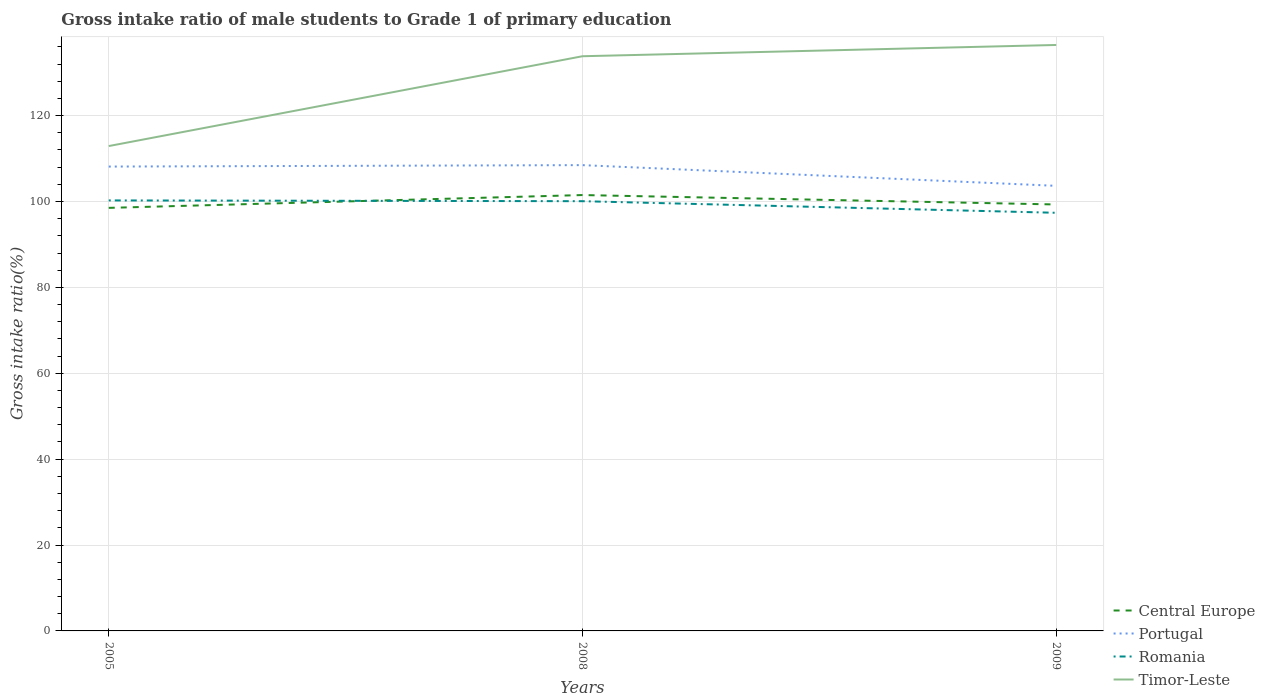How many different coloured lines are there?
Keep it short and to the point. 4. Across all years, what is the maximum gross intake ratio in Timor-Leste?
Offer a very short reply. 112.91. What is the total gross intake ratio in Timor-Leste in the graph?
Give a very brief answer. -2.62. What is the difference between the highest and the second highest gross intake ratio in Central Europe?
Keep it short and to the point. 2.98. Is the gross intake ratio in Portugal strictly greater than the gross intake ratio in Timor-Leste over the years?
Make the answer very short. Yes. How many lines are there?
Provide a short and direct response. 4. Does the graph contain grids?
Offer a very short reply. Yes. Where does the legend appear in the graph?
Provide a succinct answer. Bottom right. How are the legend labels stacked?
Keep it short and to the point. Vertical. What is the title of the graph?
Your answer should be compact. Gross intake ratio of male students to Grade 1 of primary education. What is the label or title of the X-axis?
Keep it short and to the point. Years. What is the label or title of the Y-axis?
Give a very brief answer. Gross intake ratio(%). What is the Gross intake ratio(%) in Central Europe in 2005?
Your response must be concise. 98.51. What is the Gross intake ratio(%) of Portugal in 2005?
Your response must be concise. 108.13. What is the Gross intake ratio(%) of Romania in 2005?
Your answer should be compact. 100.25. What is the Gross intake ratio(%) in Timor-Leste in 2005?
Make the answer very short. 112.91. What is the Gross intake ratio(%) in Central Europe in 2008?
Your answer should be compact. 101.5. What is the Gross intake ratio(%) of Portugal in 2008?
Make the answer very short. 108.47. What is the Gross intake ratio(%) in Romania in 2008?
Your response must be concise. 100.07. What is the Gross intake ratio(%) in Timor-Leste in 2008?
Provide a short and direct response. 133.82. What is the Gross intake ratio(%) of Central Europe in 2009?
Offer a terse response. 99.3. What is the Gross intake ratio(%) in Portugal in 2009?
Your response must be concise. 103.64. What is the Gross intake ratio(%) in Romania in 2009?
Provide a short and direct response. 97.37. What is the Gross intake ratio(%) in Timor-Leste in 2009?
Offer a very short reply. 136.45. Across all years, what is the maximum Gross intake ratio(%) in Central Europe?
Your response must be concise. 101.5. Across all years, what is the maximum Gross intake ratio(%) of Portugal?
Ensure brevity in your answer.  108.47. Across all years, what is the maximum Gross intake ratio(%) in Romania?
Your answer should be very brief. 100.25. Across all years, what is the maximum Gross intake ratio(%) in Timor-Leste?
Keep it short and to the point. 136.45. Across all years, what is the minimum Gross intake ratio(%) of Central Europe?
Provide a short and direct response. 98.51. Across all years, what is the minimum Gross intake ratio(%) of Portugal?
Offer a terse response. 103.64. Across all years, what is the minimum Gross intake ratio(%) of Romania?
Offer a terse response. 97.37. Across all years, what is the minimum Gross intake ratio(%) of Timor-Leste?
Provide a short and direct response. 112.91. What is the total Gross intake ratio(%) of Central Europe in the graph?
Offer a terse response. 299.31. What is the total Gross intake ratio(%) in Portugal in the graph?
Provide a short and direct response. 320.24. What is the total Gross intake ratio(%) of Romania in the graph?
Provide a short and direct response. 297.69. What is the total Gross intake ratio(%) of Timor-Leste in the graph?
Your answer should be compact. 383.18. What is the difference between the Gross intake ratio(%) of Central Europe in 2005 and that in 2008?
Offer a very short reply. -2.98. What is the difference between the Gross intake ratio(%) of Portugal in 2005 and that in 2008?
Make the answer very short. -0.33. What is the difference between the Gross intake ratio(%) in Romania in 2005 and that in 2008?
Make the answer very short. 0.18. What is the difference between the Gross intake ratio(%) of Timor-Leste in 2005 and that in 2008?
Provide a short and direct response. -20.92. What is the difference between the Gross intake ratio(%) of Central Europe in 2005 and that in 2009?
Provide a succinct answer. -0.79. What is the difference between the Gross intake ratio(%) of Portugal in 2005 and that in 2009?
Keep it short and to the point. 4.49. What is the difference between the Gross intake ratio(%) of Romania in 2005 and that in 2009?
Your answer should be compact. 2.88. What is the difference between the Gross intake ratio(%) of Timor-Leste in 2005 and that in 2009?
Your answer should be compact. -23.54. What is the difference between the Gross intake ratio(%) in Central Europe in 2008 and that in 2009?
Provide a short and direct response. 2.19. What is the difference between the Gross intake ratio(%) of Portugal in 2008 and that in 2009?
Offer a terse response. 4.82. What is the difference between the Gross intake ratio(%) in Romania in 2008 and that in 2009?
Give a very brief answer. 2.7. What is the difference between the Gross intake ratio(%) in Timor-Leste in 2008 and that in 2009?
Your answer should be very brief. -2.62. What is the difference between the Gross intake ratio(%) of Central Europe in 2005 and the Gross intake ratio(%) of Portugal in 2008?
Your answer should be very brief. -9.95. What is the difference between the Gross intake ratio(%) in Central Europe in 2005 and the Gross intake ratio(%) in Romania in 2008?
Give a very brief answer. -1.56. What is the difference between the Gross intake ratio(%) in Central Europe in 2005 and the Gross intake ratio(%) in Timor-Leste in 2008?
Make the answer very short. -35.31. What is the difference between the Gross intake ratio(%) in Portugal in 2005 and the Gross intake ratio(%) in Romania in 2008?
Ensure brevity in your answer.  8.06. What is the difference between the Gross intake ratio(%) in Portugal in 2005 and the Gross intake ratio(%) in Timor-Leste in 2008?
Your response must be concise. -25.69. What is the difference between the Gross intake ratio(%) of Romania in 2005 and the Gross intake ratio(%) of Timor-Leste in 2008?
Offer a terse response. -33.58. What is the difference between the Gross intake ratio(%) of Central Europe in 2005 and the Gross intake ratio(%) of Portugal in 2009?
Provide a succinct answer. -5.13. What is the difference between the Gross intake ratio(%) of Central Europe in 2005 and the Gross intake ratio(%) of Romania in 2009?
Give a very brief answer. 1.15. What is the difference between the Gross intake ratio(%) in Central Europe in 2005 and the Gross intake ratio(%) in Timor-Leste in 2009?
Offer a very short reply. -37.93. What is the difference between the Gross intake ratio(%) of Portugal in 2005 and the Gross intake ratio(%) of Romania in 2009?
Provide a short and direct response. 10.76. What is the difference between the Gross intake ratio(%) of Portugal in 2005 and the Gross intake ratio(%) of Timor-Leste in 2009?
Make the answer very short. -28.32. What is the difference between the Gross intake ratio(%) in Romania in 2005 and the Gross intake ratio(%) in Timor-Leste in 2009?
Your response must be concise. -36.2. What is the difference between the Gross intake ratio(%) in Central Europe in 2008 and the Gross intake ratio(%) in Portugal in 2009?
Provide a succinct answer. -2.14. What is the difference between the Gross intake ratio(%) of Central Europe in 2008 and the Gross intake ratio(%) of Romania in 2009?
Give a very brief answer. 4.13. What is the difference between the Gross intake ratio(%) in Central Europe in 2008 and the Gross intake ratio(%) in Timor-Leste in 2009?
Keep it short and to the point. -34.95. What is the difference between the Gross intake ratio(%) of Portugal in 2008 and the Gross intake ratio(%) of Romania in 2009?
Your response must be concise. 11.1. What is the difference between the Gross intake ratio(%) in Portugal in 2008 and the Gross intake ratio(%) in Timor-Leste in 2009?
Your answer should be very brief. -27.98. What is the difference between the Gross intake ratio(%) in Romania in 2008 and the Gross intake ratio(%) in Timor-Leste in 2009?
Make the answer very short. -36.38. What is the average Gross intake ratio(%) in Central Europe per year?
Give a very brief answer. 99.77. What is the average Gross intake ratio(%) in Portugal per year?
Your response must be concise. 106.75. What is the average Gross intake ratio(%) of Romania per year?
Keep it short and to the point. 99.23. What is the average Gross intake ratio(%) in Timor-Leste per year?
Your answer should be very brief. 127.73. In the year 2005, what is the difference between the Gross intake ratio(%) of Central Europe and Gross intake ratio(%) of Portugal?
Your answer should be very brief. -9.62. In the year 2005, what is the difference between the Gross intake ratio(%) in Central Europe and Gross intake ratio(%) in Romania?
Keep it short and to the point. -1.74. In the year 2005, what is the difference between the Gross intake ratio(%) in Central Europe and Gross intake ratio(%) in Timor-Leste?
Your response must be concise. -14.39. In the year 2005, what is the difference between the Gross intake ratio(%) in Portugal and Gross intake ratio(%) in Romania?
Provide a succinct answer. 7.88. In the year 2005, what is the difference between the Gross intake ratio(%) of Portugal and Gross intake ratio(%) of Timor-Leste?
Provide a short and direct response. -4.78. In the year 2005, what is the difference between the Gross intake ratio(%) of Romania and Gross intake ratio(%) of Timor-Leste?
Your answer should be compact. -12.66. In the year 2008, what is the difference between the Gross intake ratio(%) of Central Europe and Gross intake ratio(%) of Portugal?
Provide a succinct answer. -6.97. In the year 2008, what is the difference between the Gross intake ratio(%) in Central Europe and Gross intake ratio(%) in Romania?
Ensure brevity in your answer.  1.43. In the year 2008, what is the difference between the Gross intake ratio(%) in Central Europe and Gross intake ratio(%) in Timor-Leste?
Your answer should be very brief. -32.33. In the year 2008, what is the difference between the Gross intake ratio(%) in Portugal and Gross intake ratio(%) in Romania?
Ensure brevity in your answer.  8.4. In the year 2008, what is the difference between the Gross intake ratio(%) of Portugal and Gross intake ratio(%) of Timor-Leste?
Your response must be concise. -25.36. In the year 2008, what is the difference between the Gross intake ratio(%) in Romania and Gross intake ratio(%) in Timor-Leste?
Offer a terse response. -33.76. In the year 2009, what is the difference between the Gross intake ratio(%) of Central Europe and Gross intake ratio(%) of Portugal?
Provide a succinct answer. -4.34. In the year 2009, what is the difference between the Gross intake ratio(%) of Central Europe and Gross intake ratio(%) of Romania?
Provide a short and direct response. 1.94. In the year 2009, what is the difference between the Gross intake ratio(%) of Central Europe and Gross intake ratio(%) of Timor-Leste?
Make the answer very short. -37.14. In the year 2009, what is the difference between the Gross intake ratio(%) in Portugal and Gross intake ratio(%) in Romania?
Your answer should be compact. 6.27. In the year 2009, what is the difference between the Gross intake ratio(%) in Portugal and Gross intake ratio(%) in Timor-Leste?
Your answer should be very brief. -32.81. In the year 2009, what is the difference between the Gross intake ratio(%) in Romania and Gross intake ratio(%) in Timor-Leste?
Your response must be concise. -39.08. What is the ratio of the Gross intake ratio(%) of Central Europe in 2005 to that in 2008?
Your response must be concise. 0.97. What is the ratio of the Gross intake ratio(%) of Portugal in 2005 to that in 2008?
Ensure brevity in your answer.  1. What is the ratio of the Gross intake ratio(%) in Romania in 2005 to that in 2008?
Give a very brief answer. 1. What is the ratio of the Gross intake ratio(%) of Timor-Leste in 2005 to that in 2008?
Your answer should be very brief. 0.84. What is the ratio of the Gross intake ratio(%) of Central Europe in 2005 to that in 2009?
Give a very brief answer. 0.99. What is the ratio of the Gross intake ratio(%) in Portugal in 2005 to that in 2009?
Offer a terse response. 1.04. What is the ratio of the Gross intake ratio(%) of Romania in 2005 to that in 2009?
Offer a very short reply. 1.03. What is the ratio of the Gross intake ratio(%) in Timor-Leste in 2005 to that in 2009?
Keep it short and to the point. 0.83. What is the ratio of the Gross intake ratio(%) in Central Europe in 2008 to that in 2009?
Provide a succinct answer. 1.02. What is the ratio of the Gross intake ratio(%) in Portugal in 2008 to that in 2009?
Provide a short and direct response. 1.05. What is the ratio of the Gross intake ratio(%) in Romania in 2008 to that in 2009?
Make the answer very short. 1.03. What is the ratio of the Gross intake ratio(%) in Timor-Leste in 2008 to that in 2009?
Offer a terse response. 0.98. What is the difference between the highest and the second highest Gross intake ratio(%) in Central Europe?
Your answer should be very brief. 2.19. What is the difference between the highest and the second highest Gross intake ratio(%) of Portugal?
Ensure brevity in your answer.  0.33. What is the difference between the highest and the second highest Gross intake ratio(%) of Romania?
Offer a very short reply. 0.18. What is the difference between the highest and the second highest Gross intake ratio(%) in Timor-Leste?
Your answer should be compact. 2.62. What is the difference between the highest and the lowest Gross intake ratio(%) in Central Europe?
Ensure brevity in your answer.  2.98. What is the difference between the highest and the lowest Gross intake ratio(%) of Portugal?
Your response must be concise. 4.82. What is the difference between the highest and the lowest Gross intake ratio(%) in Romania?
Provide a short and direct response. 2.88. What is the difference between the highest and the lowest Gross intake ratio(%) of Timor-Leste?
Ensure brevity in your answer.  23.54. 